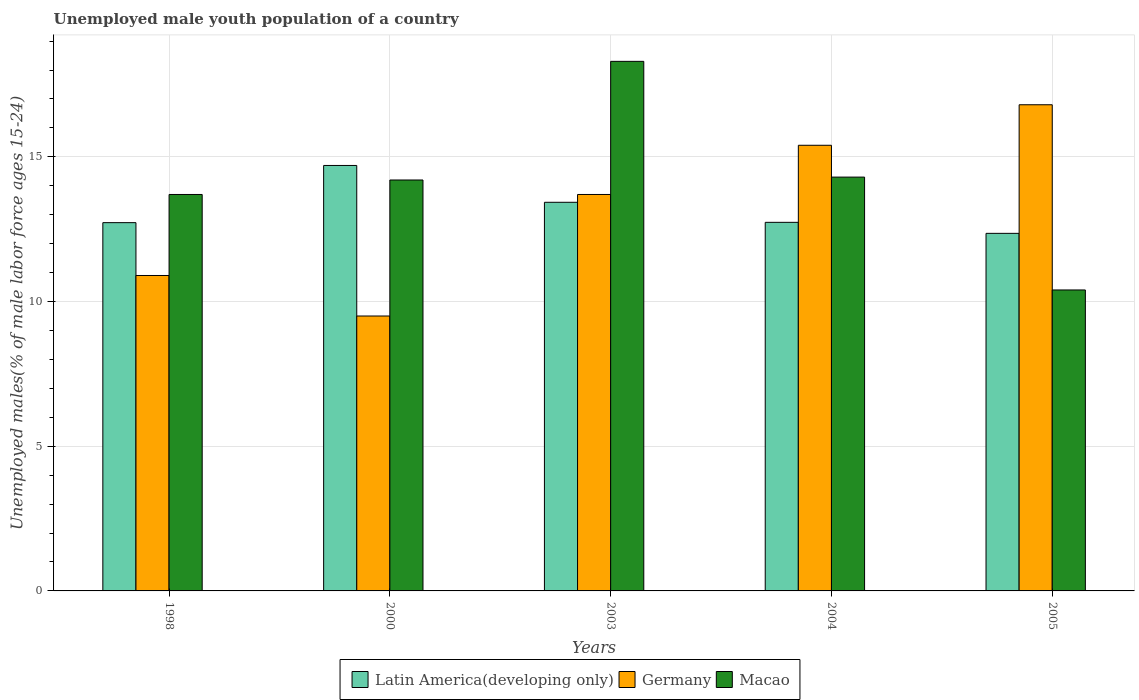How many different coloured bars are there?
Ensure brevity in your answer.  3. Are the number of bars on each tick of the X-axis equal?
Ensure brevity in your answer.  Yes. How many bars are there on the 5th tick from the left?
Ensure brevity in your answer.  3. How many bars are there on the 5th tick from the right?
Make the answer very short. 3. In how many cases, is the number of bars for a given year not equal to the number of legend labels?
Keep it short and to the point. 0. Across all years, what is the maximum percentage of unemployed male youth population in Macao?
Keep it short and to the point. 18.3. In which year was the percentage of unemployed male youth population in Macao maximum?
Provide a short and direct response. 2003. What is the total percentage of unemployed male youth population in Latin America(developing only) in the graph?
Your answer should be compact. 65.95. What is the difference between the percentage of unemployed male youth population in Germany in 2004 and that in 2005?
Offer a very short reply. -1.4. What is the difference between the percentage of unemployed male youth population in Macao in 2003 and the percentage of unemployed male youth population in Latin America(developing only) in 1998?
Give a very brief answer. 5.57. What is the average percentage of unemployed male youth population in Germany per year?
Provide a succinct answer. 13.26. In the year 2003, what is the difference between the percentage of unemployed male youth population in Germany and percentage of unemployed male youth population in Macao?
Your answer should be compact. -4.6. What is the ratio of the percentage of unemployed male youth population in Germany in 2000 to that in 2003?
Your answer should be very brief. 0.69. Is the percentage of unemployed male youth population in Latin America(developing only) in 2000 less than that in 2005?
Provide a succinct answer. No. Is the difference between the percentage of unemployed male youth population in Germany in 2000 and 2005 greater than the difference between the percentage of unemployed male youth population in Macao in 2000 and 2005?
Offer a very short reply. No. What is the difference between the highest and the second highest percentage of unemployed male youth population in Germany?
Your answer should be compact. 1.4. What is the difference between the highest and the lowest percentage of unemployed male youth population in Germany?
Offer a very short reply. 7.3. Is the sum of the percentage of unemployed male youth population in Latin America(developing only) in 1998 and 2004 greater than the maximum percentage of unemployed male youth population in Macao across all years?
Your answer should be compact. Yes. What does the 2nd bar from the left in 1998 represents?
Provide a short and direct response. Germany. What does the 3rd bar from the right in 2004 represents?
Make the answer very short. Latin America(developing only). How many bars are there?
Offer a terse response. 15. What is the difference between two consecutive major ticks on the Y-axis?
Make the answer very short. 5. What is the title of the graph?
Keep it short and to the point. Unemployed male youth population of a country. What is the label or title of the X-axis?
Your answer should be very brief. Years. What is the label or title of the Y-axis?
Provide a succinct answer. Unemployed males(% of male labor force ages 15-24). What is the Unemployed males(% of male labor force ages 15-24) of Latin America(developing only) in 1998?
Make the answer very short. 12.73. What is the Unemployed males(% of male labor force ages 15-24) of Germany in 1998?
Provide a short and direct response. 10.9. What is the Unemployed males(% of male labor force ages 15-24) in Macao in 1998?
Your answer should be compact. 13.7. What is the Unemployed males(% of male labor force ages 15-24) of Latin America(developing only) in 2000?
Keep it short and to the point. 14.7. What is the Unemployed males(% of male labor force ages 15-24) of Germany in 2000?
Provide a succinct answer. 9.5. What is the Unemployed males(% of male labor force ages 15-24) in Macao in 2000?
Keep it short and to the point. 14.2. What is the Unemployed males(% of male labor force ages 15-24) of Latin America(developing only) in 2003?
Offer a terse response. 13.43. What is the Unemployed males(% of male labor force ages 15-24) in Germany in 2003?
Keep it short and to the point. 13.7. What is the Unemployed males(% of male labor force ages 15-24) in Macao in 2003?
Provide a short and direct response. 18.3. What is the Unemployed males(% of male labor force ages 15-24) of Latin America(developing only) in 2004?
Provide a short and direct response. 12.74. What is the Unemployed males(% of male labor force ages 15-24) in Germany in 2004?
Your response must be concise. 15.4. What is the Unemployed males(% of male labor force ages 15-24) of Macao in 2004?
Your response must be concise. 14.3. What is the Unemployed males(% of male labor force ages 15-24) of Latin America(developing only) in 2005?
Make the answer very short. 12.36. What is the Unemployed males(% of male labor force ages 15-24) in Germany in 2005?
Provide a short and direct response. 16.8. What is the Unemployed males(% of male labor force ages 15-24) in Macao in 2005?
Your answer should be compact. 10.4. Across all years, what is the maximum Unemployed males(% of male labor force ages 15-24) in Latin America(developing only)?
Your response must be concise. 14.7. Across all years, what is the maximum Unemployed males(% of male labor force ages 15-24) in Germany?
Keep it short and to the point. 16.8. Across all years, what is the maximum Unemployed males(% of male labor force ages 15-24) of Macao?
Provide a short and direct response. 18.3. Across all years, what is the minimum Unemployed males(% of male labor force ages 15-24) of Latin America(developing only)?
Offer a terse response. 12.36. Across all years, what is the minimum Unemployed males(% of male labor force ages 15-24) in Germany?
Offer a terse response. 9.5. Across all years, what is the minimum Unemployed males(% of male labor force ages 15-24) of Macao?
Your response must be concise. 10.4. What is the total Unemployed males(% of male labor force ages 15-24) of Latin America(developing only) in the graph?
Give a very brief answer. 65.95. What is the total Unemployed males(% of male labor force ages 15-24) in Germany in the graph?
Offer a very short reply. 66.3. What is the total Unemployed males(% of male labor force ages 15-24) of Macao in the graph?
Offer a very short reply. 70.9. What is the difference between the Unemployed males(% of male labor force ages 15-24) in Latin America(developing only) in 1998 and that in 2000?
Make the answer very short. -1.98. What is the difference between the Unemployed males(% of male labor force ages 15-24) of Macao in 1998 and that in 2000?
Provide a short and direct response. -0.5. What is the difference between the Unemployed males(% of male labor force ages 15-24) in Latin America(developing only) in 1998 and that in 2003?
Offer a terse response. -0.7. What is the difference between the Unemployed males(% of male labor force ages 15-24) in Latin America(developing only) in 1998 and that in 2004?
Provide a short and direct response. -0.01. What is the difference between the Unemployed males(% of male labor force ages 15-24) of Germany in 1998 and that in 2004?
Ensure brevity in your answer.  -4.5. What is the difference between the Unemployed males(% of male labor force ages 15-24) in Macao in 1998 and that in 2004?
Provide a succinct answer. -0.6. What is the difference between the Unemployed males(% of male labor force ages 15-24) in Latin America(developing only) in 1998 and that in 2005?
Your response must be concise. 0.37. What is the difference between the Unemployed males(% of male labor force ages 15-24) of Macao in 1998 and that in 2005?
Your answer should be very brief. 3.3. What is the difference between the Unemployed males(% of male labor force ages 15-24) in Latin America(developing only) in 2000 and that in 2003?
Provide a succinct answer. 1.27. What is the difference between the Unemployed males(% of male labor force ages 15-24) in Macao in 2000 and that in 2003?
Your answer should be compact. -4.1. What is the difference between the Unemployed males(% of male labor force ages 15-24) of Latin America(developing only) in 2000 and that in 2004?
Offer a terse response. 1.97. What is the difference between the Unemployed males(% of male labor force ages 15-24) in Germany in 2000 and that in 2004?
Your answer should be compact. -5.9. What is the difference between the Unemployed males(% of male labor force ages 15-24) of Macao in 2000 and that in 2004?
Ensure brevity in your answer.  -0.1. What is the difference between the Unemployed males(% of male labor force ages 15-24) in Latin America(developing only) in 2000 and that in 2005?
Keep it short and to the point. 2.35. What is the difference between the Unemployed males(% of male labor force ages 15-24) in Macao in 2000 and that in 2005?
Provide a short and direct response. 3.8. What is the difference between the Unemployed males(% of male labor force ages 15-24) of Latin America(developing only) in 2003 and that in 2004?
Give a very brief answer. 0.69. What is the difference between the Unemployed males(% of male labor force ages 15-24) in Latin America(developing only) in 2003 and that in 2005?
Offer a very short reply. 1.07. What is the difference between the Unemployed males(% of male labor force ages 15-24) of Latin America(developing only) in 2004 and that in 2005?
Make the answer very short. 0.38. What is the difference between the Unemployed males(% of male labor force ages 15-24) in Germany in 2004 and that in 2005?
Ensure brevity in your answer.  -1.4. What is the difference between the Unemployed males(% of male labor force ages 15-24) in Macao in 2004 and that in 2005?
Provide a succinct answer. 3.9. What is the difference between the Unemployed males(% of male labor force ages 15-24) in Latin America(developing only) in 1998 and the Unemployed males(% of male labor force ages 15-24) in Germany in 2000?
Give a very brief answer. 3.23. What is the difference between the Unemployed males(% of male labor force ages 15-24) in Latin America(developing only) in 1998 and the Unemployed males(% of male labor force ages 15-24) in Macao in 2000?
Ensure brevity in your answer.  -1.47. What is the difference between the Unemployed males(% of male labor force ages 15-24) in Germany in 1998 and the Unemployed males(% of male labor force ages 15-24) in Macao in 2000?
Offer a terse response. -3.3. What is the difference between the Unemployed males(% of male labor force ages 15-24) in Latin America(developing only) in 1998 and the Unemployed males(% of male labor force ages 15-24) in Germany in 2003?
Keep it short and to the point. -0.97. What is the difference between the Unemployed males(% of male labor force ages 15-24) of Latin America(developing only) in 1998 and the Unemployed males(% of male labor force ages 15-24) of Macao in 2003?
Ensure brevity in your answer.  -5.57. What is the difference between the Unemployed males(% of male labor force ages 15-24) of Latin America(developing only) in 1998 and the Unemployed males(% of male labor force ages 15-24) of Germany in 2004?
Offer a very short reply. -2.67. What is the difference between the Unemployed males(% of male labor force ages 15-24) in Latin America(developing only) in 1998 and the Unemployed males(% of male labor force ages 15-24) in Macao in 2004?
Your response must be concise. -1.57. What is the difference between the Unemployed males(% of male labor force ages 15-24) of Germany in 1998 and the Unemployed males(% of male labor force ages 15-24) of Macao in 2004?
Give a very brief answer. -3.4. What is the difference between the Unemployed males(% of male labor force ages 15-24) of Latin America(developing only) in 1998 and the Unemployed males(% of male labor force ages 15-24) of Germany in 2005?
Offer a very short reply. -4.07. What is the difference between the Unemployed males(% of male labor force ages 15-24) of Latin America(developing only) in 1998 and the Unemployed males(% of male labor force ages 15-24) of Macao in 2005?
Your answer should be very brief. 2.33. What is the difference between the Unemployed males(% of male labor force ages 15-24) in Germany in 1998 and the Unemployed males(% of male labor force ages 15-24) in Macao in 2005?
Provide a succinct answer. 0.5. What is the difference between the Unemployed males(% of male labor force ages 15-24) of Latin America(developing only) in 2000 and the Unemployed males(% of male labor force ages 15-24) of Germany in 2003?
Your answer should be compact. 1. What is the difference between the Unemployed males(% of male labor force ages 15-24) in Latin America(developing only) in 2000 and the Unemployed males(% of male labor force ages 15-24) in Macao in 2003?
Provide a short and direct response. -3.6. What is the difference between the Unemployed males(% of male labor force ages 15-24) of Latin America(developing only) in 2000 and the Unemployed males(% of male labor force ages 15-24) of Germany in 2004?
Offer a very short reply. -0.7. What is the difference between the Unemployed males(% of male labor force ages 15-24) of Latin America(developing only) in 2000 and the Unemployed males(% of male labor force ages 15-24) of Macao in 2004?
Provide a succinct answer. 0.4. What is the difference between the Unemployed males(% of male labor force ages 15-24) of Germany in 2000 and the Unemployed males(% of male labor force ages 15-24) of Macao in 2004?
Provide a succinct answer. -4.8. What is the difference between the Unemployed males(% of male labor force ages 15-24) in Latin America(developing only) in 2000 and the Unemployed males(% of male labor force ages 15-24) in Germany in 2005?
Your response must be concise. -2.1. What is the difference between the Unemployed males(% of male labor force ages 15-24) in Latin America(developing only) in 2000 and the Unemployed males(% of male labor force ages 15-24) in Macao in 2005?
Keep it short and to the point. 4.3. What is the difference between the Unemployed males(% of male labor force ages 15-24) of Germany in 2000 and the Unemployed males(% of male labor force ages 15-24) of Macao in 2005?
Make the answer very short. -0.9. What is the difference between the Unemployed males(% of male labor force ages 15-24) of Latin America(developing only) in 2003 and the Unemployed males(% of male labor force ages 15-24) of Germany in 2004?
Your answer should be compact. -1.97. What is the difference between the Unemployed males(% of male labor force ages 15-24) in Latin America(developing only) in 2003 and the Unemployed males(% of male labor force ages 15-24) in Macao in 2004?
Keep it short and to the point. -0.87. What is the difference between the Unemployed males(% of male labor force ages 15-24) of Germany in 2003 and the Unemployed males(% of male labor force ages 15-24) of Macao in 2004?
Give a very brief answer. -0.6. What is the difference between the Unemployed males(% of male labor force ages 15-24) of Latin America(developing only) in 2003 and the Unemployed males(% of male labor force ages 15-24) of Germany in 2005?
Keep it short and to the point. -3.37. What is the difference between the Unemployed males(% of male labor force ages 15-24) in Latin America(developing only) in 2003 and the Unemployed males(% of male labor force ages 15-24) in Macao in 2005?
Ensure brevity in your answer.  3.03. What is the difference between the Unemployed males(% of male labor force ages 15-24) in Germany in 2003 and the Unemployed males(% of male labor force ages 15-24) in Macao in 2005?
Your answer should be compact. 3.3. What is the difference between the Unemployed males(% of male labor force ages 15-24) in Latin America(developing only) in 2004 and the Unemployed males(% of male labor force ages 15-24) in Germany in 2005?
Ensure brevity in your answer.  -4.06. What is the difference between the Unemployed males(% of male labor force ages 15-24) of Latin America(developing only) in 2004 and the Unemployed males(% of male labor force ages 15-24) of Macao in 2005?
Offer a terse response. 2.34. What is the difference between the Unemployed males(% of male labor force ages 15-24) of Germany in 2004 and the Unemployed males(% of male labor force ages 15-24) of Macao in 2005?
Keep it short and to the point. 5. What is the average Unemployed males(% of male labor force ages 15-24) in Latin America(developing only) per year?
Keep it short and to the point. 13.19. What is the average Unemployed males(% of male labor force ages 15-24) of Germany per year?
Keep it short and to the point. 13.26. What is the average Unemployed males(% of male labor force ages 15-24) in Macao per year?
Your answer should be very brief. 14.18. In the year 1998, what is the difference between the Unemployed males(% of male labor force ages 15-24) of Latin America(developing only) and Unemployed males(% of male labor force ages 15-24) of Germany?
Your answer should be compact. 1.83. In the year 1998, what is the difference between the Unemployed males(% of male labor force ages 15-24) in Latin America(developing only) and Unemployed males(% of male labor force ages 15-24) in Macao?
Make the answer very short. -0.97. In the year 1998, what is the difference between the Unemployed males(% of male labor force ages 15-24) in Germany and Unemployed males(% of male labor force ages 15-24) in Macao?
Provide a succinct answer. -2.8. In the year 2000, what is the difference between the Unemployed males(% of male labor force ages 15-24) in Latin America(developing only) and Unemployed males(% of male labor force ages 15-24) in Germany?
Provide a short and direct response. 5.2. In the year 2000, what is the difference between the Unemployed males(% of male labor force ages 15-24) of Latin America(developing only) and Unemployed males(% of male labor force ages 15-24) of Macao?
Provide a succinct answer. 0.5. In the year 2000, what is the difference between the Unemployed males(% of male labor force ages 15-24) in Germany and Unemployed males(% of male labor force ages 15-24) in Macao?
Ensure brevity in your answer.  -4.7. In the year 2003, what is the difference between the Unemployed males(% of male labor force ages 15-24) in Latin America(developing only) and Unemployed males(% of male labor force ages 15-24) in Germany?
Provide a short and direct response. -0.27. In the year 2003, what is the difference between the Unemployed males(% of male labor force ages 15-24) of Latin America(developing only) and Unemployed males(% of male labor force ages 15-24) of Macao?
Make the answer very short. -4.87. In the year 2003, what is the difference between the Unemployed males(% of male labor force ages 15-24) in Germany and Unemployed males(% of male labor force ages 15-24) in Macao?
Give a very brief answer. -4.6. In the year 2004, what is the difference between the Unemployed males(% of male labor force ages 15-24) of Latin America(developing only) and Unemployed males(% of male labor force ages 15-24) of Germany?
Your answer should be compact. -2.66. In the year 2004, what is the difference between the Unemployed males(% of male labor force ages 15-24) in Latin America(developing only) and Unemployed males(% of male labor force ages 15-24) in Macao?
Offer a terse response. -1.56. In the year 2004, what is the difference between the Unemployed males(% of male labor force ages 15-24) in Germany and Unemployed males(% of male labor force ages 15-24) in Macao?
Offer a terse response. 1.1. In the year 2005, what is the difference between the Unemployed males(% of male labor force ages 15-24) in Latin America(developing only) and Unemployed males(% of male labor force ages 15-24) in Germany?
Your response must be concise. -4.44. In the year 2005, what is the difference between the Unemployed males(% of male labor force ages 15-24) in Latin America(developing only) and Unemployed males(% of male labor force ages 15-24) in Macao?
Ensure brevity in your answer.  1.96. What is the ratio of the Unemployed males(% of male labor force ages 15-24) of Latin America(developing only) in 1998 to that in 2000?
Provide a succinct answer. 0.87. What is the ratio of the Unemployed males(% of male labor force ages 15-24) of Germany in 1998 to that in 2000?
Give a very brief answer. 1.15. What is the ratio of the Unemployed males(% of male labor force ages 15-24) in Macao in 1998 to that in 2000?
Make the answer very short. 0.96. What is the ratio of the Unemployed males(% of male labor force ages 15-24) in Latin America(developing only) in 1998 to that in 2003?
Keep it short and to the point. 0.95. What is the ratio of the Unemployed males(% of male labor force ages 15-24) of Germany in 1998 to that in 2003?
Your answer should be compact. 0.8. What is the ratio of the Unemployed males(% of male labor force ages 15-24) in Macao in 1998 to that in 2003?
Give a very brief answer. 0.75. What is the ratio of the Unemployed males(% of male labor force ages 15-24) of Germany in 1998 to that in 2004?
Provide a short and direct response. 0.71. What is the ratio of the Unemployed males(% of male labor force ages 15-24) of Macao in 1998 to that in 2004?
Ensure brevity in your answer.  0.96. What is the ratio of the Unemployed males(% of male labor force ages 15-24) in Latin America(developing only) in 1998 to that in 2005?
Your response must be concise. 1.03. What is the ratio of the Unemployed males(% of male labor force ages 15-24) of Germany in 1998 to that in 2005?
Make the answer very short. 0.65. What is the ratio of the Unemployed males(% of male labor force ages 15-24) of Macao in 1998 to that in 2005?
Provide a succinct answer. 1.32. What is the ratio of the Unemployed males(% of male labor force ages 15-24) in Latin America(developing only) in 2000 to that in 2003?
Your answer should be very brief. 1.09. What is the ratio of the Unemployed males(% of male labor force ages 15-24) of Germany in 2000 to that in 2003?
Offer a very short reply. 0.69. What is the ratio of the Unemployed males(% of male labor force ages 15-24) in Macao in 2000 to that in 2003?
Your response must be concise. 0.78. What is the ratio of the Unemployed males(% of male labor force ages 15-24) of Latin America(developing only) in 2000 to that in 2004?
Provide a succinct answer. 1.15. What is the ratio of the Unemployed males(% of male labor force ages 15-24) of Germany in 2000 to that in 2004?
Give a very brief answer. 0.62. What is the ratio of the Unemployed males(% of male labor force ages 15-24) in Latin America(developing only) in 2000 to that in 2005?
Your response must be concise. 1.19. What is the ratio of the Unemployed males(% of male labor force ages 15-24) of Germany in 2000 to that in 2005?
Keep it short and to the point. 0.57. What is the ratio of the Unemployed males(% of male labor force ages 15-24) in Macao in 2000 to that in 2005?
Keep it short and to the point. 1.37. What is the ratio of the Unemployed males(% of male labor force ages 15-24) in Latin America(developing only) in 2003 to that in 2004?
Your response must be concise. 1.05. What is the ratio of the Unemployed males(% of male labor force ages 15-24) in Germany in 2003 to that in 2004?
Offer a very short reply. 0.89. What is the ratio of the Unemployed males(% of male labor force ages 15-24) of Macao in 2003 to that in 2004?
Your answer should be compact. 1.28. What is the ratio of the Unemployed males(% of male labor force ages 15-24) in Latin America(developing only) in 2003 to that in 2005?
Your answer should be compact. 1.09. What is the ratio of the Unemployed males(% of male labor force ages 15-24) in Germany in 2003 to that in 2005?
Keep it short and to the point. 0.82. What is the ratio of the Unemployed males(% of male labor force ages 15-24) in Macao in 2003 to that in 2005?
Make the answer very short. 1.76. What is the ratio of the Unemployed males(% of male labor force ages 15-24) of Latin America(developing only) in 2004 to that in 2005?
Your response must be concise. 1.03. What is the ratio of the Unemployed males(% of male labor force ages 15-24) in Macao in 2004 to that in 2005?
Offer a very short reply. 1.38. What is the difference between the highest and the second highest Unemployed males(% of male labor force ages 15-24) of Latin America(developing only)?
Your answer should be compact. 1.27. What is the difference between the highest and the second highest Unemployed males(% of male labor force ages 15-24) of Macao?
Make the answer very short. 4. What is the difference between the highest and the lowest Unemployed males(% of male labor force ages 15-24) in Latin America(developing only)?
Offer a very short reply. 2.35. What is the difference between the highest and the lowest Unemployed males(% of male labor force ages 15-24) in Germany?
Ensure brevity in your answer.  7.3. 